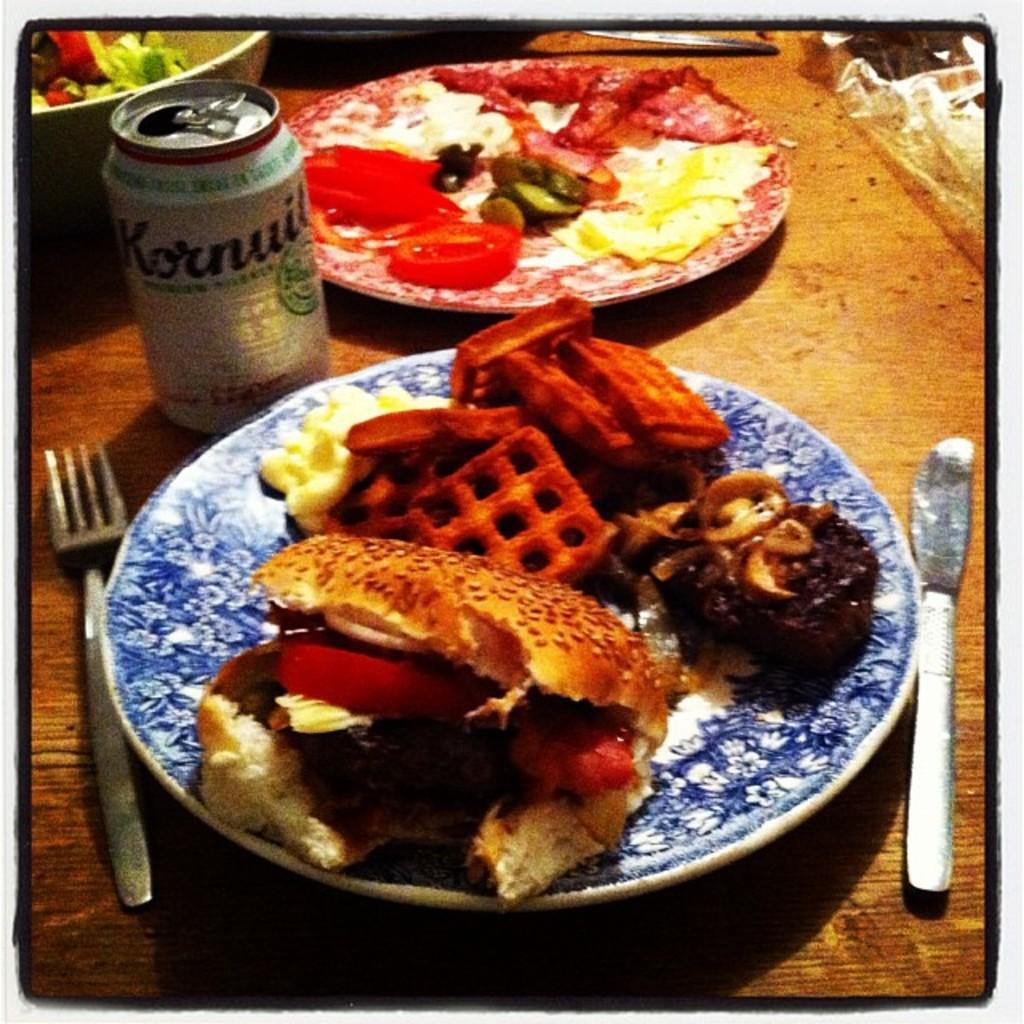Could you give a brief overview of what you see in this image? In this image we can see the food items in two different plates and one bowl. We can also see the tin, fork and a butter knife on the wooden surface and the image has borders. 